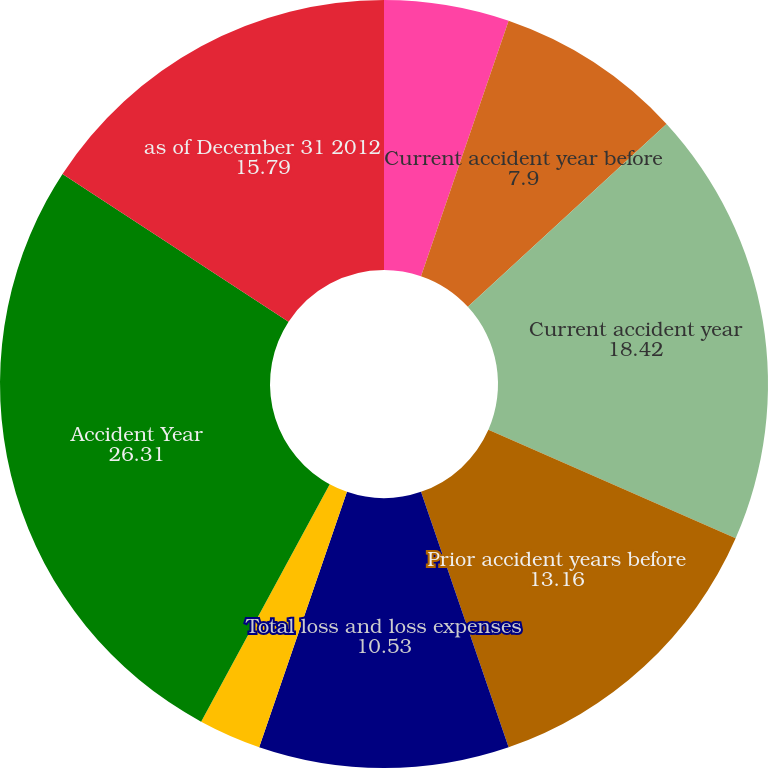Convert chart. <chart><loc_0><loc_0><loc_500><loc_500><pie_chart><fcel>Net written premiums<fcel>Current accident year before<fcel>Current accident year<fcel>Prior accident years before<fcel>Total loss and loss expenses<fcel>Prior accident years<fcel>Total loss and loss expense<fcel>Accident Year<fcel>as of December 31 2012<nl><fcel>5.26%<fcel>7.9%<fcel>18.42%<fcel>13.16%<fcel>10.53%<fcel>0.0%<fcel>2.63%<fcel>26.31%<fcel>15.79%<nl></chart> 